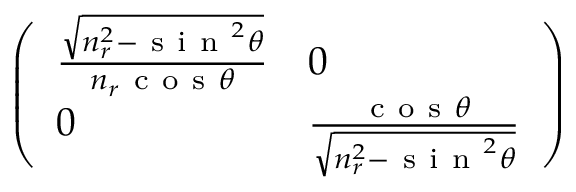<formula> <loc_0><loc_0><loc_500><loc_500>\left ( \begin{array} { l l } { \frac { \sqrt { n _ { r } ^ { 2 } - s i n ^ { 2 } \theta } } { n _ { r } c o s \theta } } & { 0 } \\ { 0 } & { \frac { c o s \theta } { \sqrt { n _ { r } ^ { 2 } - s i n ^ { 2 } \theta } } } \end{array} \right )</formula> 